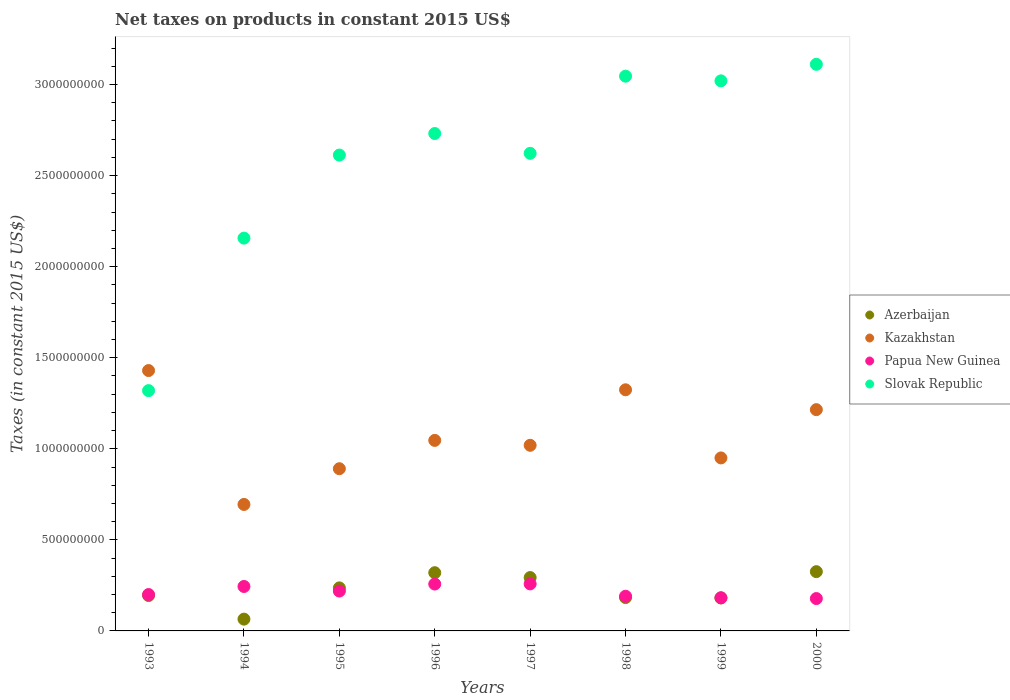Is the number of dotlines equal to the number of legend labels?
Your response must be concise. Yes. What is the net taxes on products in Kazakhstan in 1993?
Offer a very short reply. 1.43e+09. Across all years, what is the maximum net taxes on products in Kazakhstan?
Offer a very short reply. 1.43e+09. Across all years, what is the minimum net taxes on products in Papua New Guinea?
Provide a short and direct response. 1.78e+08. What is the total net taxes on products in Azerbaijan in the graph?
Offer a terse response. 1.80e+09. What is the difference between the net taxes on products in Azerbaijan in 1997 and that in 1999?
Your answer should be very brief. 1.12e+08. What is the difference between the net taxes on products in Slovak Republic in 1998 and the net taxes on products in Papua New Guinea in 1997?
Provide a short and direct response. 2.79e+09. What is the average net taxes on products in Slovak Republic per year?
Keep it short and to the point. 2.58e+09. In the year 1999, what is the difference between the net taxes on products in Kazakhstan and net taxes on products in Azerbaijan?
Your answer should be very brief. 7.69e+08. What is the ratio of the net taxes on products in Azerbaijan in 1995 to that in 2000?
Ensure brevity in your answer.  0.73. Is the net taxes on products in Kazakhstan in 1996 less than that in 1997?
Provide a short and direct response. No. What is the difference between the highest and the second highest net taxes on products in Papua New Guinea?
Give a very brief answer. 7.72e+05. What is the difference between the highest and the lowest net taxes on products in Slovak Republic?
Keep it short and to the point. 1.79e+09. In how many years, is the net taxes on products in Papua New Guinea greater than the average net taxes on products in Papua New Guinea taken over all years?
Keep it short and to the point. 4. Is the sum of the net taxes on products in Slovak Republic in 1995 and 2000 greater than the maximum net taxes on products in Papua New Guinea across all years?
Your response must be concise. Yes. Is it the case that in every year, the sum of the net taxes on products in Azerbaijan and net taxes on products in Kazakhstan  is greater than the sum of net taxes on products in Papua New Guinea and net taxes on products in Slovak Republic?
Keep it short and to the point. Yes. Does the net taxes on products in Slovak Republic monotonically increase over the years?
Offer a very short reply. No. Is the net taxes on products in Slovak Republic strictly greater than the net taxes on products in Kazakhstan over the years?
Offer a very short reply. No. Is the net taxes on products in Slovak Republic strictly less than the net taxes on products in Azerbaijan over the years?
Your answer should be compact. No. How many dotlines are there?
Your answer should be very brief. 4. What is the difference between two consecutive major ticks on the Y-axis?
Offer a terse response. 5.00e+08. Does the graph contain any zero values?
Give a very brief answer. No. How many legend labels are there?
Offer a terse response. 4. How are the legend labels stacked?
Offer a very short reply. Vertical. What is the title of the graph?
Give a very brief answer. Net taxes on products in constant 2015 US$. Does "Kyrgyz Republic" appear as one of the legend labels in the graph?
Ensure brevity in your answer.  No. What is the label or title of the Y-axis?
Your answer should be very brief. Taxes (in constant 2015 US$). What is the Taxes (in constant 2015 US$) in Azerbaijan in 1993?
Make the answer very short. 1.94e+08. What is the Taxes (in constant 2015 US$) in Kazakhstan in 1993?
Your response must be concise. 1.43e+09. What is the Taxes (in constant 2015 US$) in Papua New Guinea in 1993?
Offer a terse response. 2.00e+08. What is the Taxes (in constant 2015 US$) of Slovak Republic in 1993?
Offer a terse response. 1.32e+09. What is the Taxes (in constant 2015 US$) in Azerbaijan in 1994?
Keep it short and to the point. 6.47e+07. What is the Taxes (in constant 2015 US$) in Kazakhstan in 1994?
Make the answer very short. 6.94e+08. What is the Taxes (in constant 2015 US$) of Papua New Guinea in 1994?
Keep it short and to the point. 2.44e+08. What is the Taxes (in constant 2015 US$) of Slovak Republic in 1994?
Your response must be concise. 2.16e+09. What is the Taxes (in constant 2015 US$) of Azerbaijan in 1995?
Make the answer very short. 2.36e+08. What is the Taxes (in constant 2015 US$) in Kazakhstan in 1995?
Provide a succinct answer. 8.91e+08. What is the Taxes (in constant 2015 US$) in Papua New Guinea in 1995?
Make the answer very short. 2.19e+08. What is the Taxes (in constant 2015 US$) in Slovak Republic in 1995?
Provide a succinct answer. 2.61e+09. What is the Taxes (in constant 2015 US$) of Azerbaijan in 1996?
Offer a terse response. 3.20e+08. What is the Taxes (in constant 2015 US$) in Kazakhstan in 1996?
Keep it short and to the point. 1.05e+09. What is the Taxes (in constant 2015 US$) in Papua New Guinea in 1996?
Your answer should be compact. 2.57e+08. What is the Taxes (in constant 2015 US$) of Slovak Republic in 1996?
Your response must be concise. 2.73e+09. What is the Taxes (in constant 2015 US$) of Azerbaijan in 1997?
Your answer should be compact. 2.93e+08. What is the Taxes (in constant 2015 US$) of Kazakhstan in 1997?
Ensure brevity in your answer.  1.02e+09. What is the Taxes (in constant 2015 US$) of Papua New Guinea in 1997?
Your answer should be very brief. 2.58e+08. What is the Taxes (in constant 2015 US$) of Slovak Republic in 1997?
Your response must be concise. 2.62e+09. What is the Taxes (in constant 2015 US$) in Azerbaijan in 1998?
Your answer should be very brief. 1.83e+08. What is the Taxes (in constant 2015 US$) in Kazakhstan in 1998?
Your answer should be compact. 1.32e+09. What is the Taxes (in constant 2015 US$) in Papua New Guinea in 1998?
Your answer should be very brief. 1.90e+08. What is the Taxes (in constant 2015 US$) in Slovak Republic in 1998?
Provide a succinct answer. 3.05e+09. What is the Taxes (in constant 2015 US$) in Azerbaijan in 1999?
Make the answer very short. 1.81e+08. What is the Taxes (in constant 2015 US$) of Kazakhstan in 1999?
Provide a short and direct response. 9.50e+08. What is the Taxes (in constant 2015 US$) of Papua New Guinea in 1999?
Your answer should be very brief. 1.82e+08. What is the Taxes (in constant 2015 US$) of Slovak Republic in 1999?
Your answer should be compact. 3.02e+09. What is the Taxes (in constant 2015 US$) of Azerbaijan in 2000?
Offer a terse response. 3.25e+08. What is the Taxes (in constant 2015 US$) in Kazakhstan in 2000?
Offer a very short reply. 1.21e+09. What is the Taxes (in constant 2015 US$) of Papua New Guinea in 2000?
Give a very brief answer. 1.78e+08. What is the Taxes (in constant 2015 US$) in Slovak Republic in 2000?
Your answer should be compact. 3.11e+09. Across all years, what is the maximum Taxes (in constant 2015 US$) in Azerbaijan?
Ensure brevity in your answer.  3.25e+08. Across all years, what is the maximum Taxes (in constant 2015 US$) of Kazakhstan?
Keep it short and to the point. 1.43e+09. Across all years, what is the maximum Taxes (in constant 2015 US$) in Papua New Guinea?
Provide a short and direct response. 2.58e+08. Across all years, what is the maximum Taxes (in constant 2015 US$) in Slovak Republic?
Your answer should be very brief. 3.11e+09. Across all years, what is the minimum Taxes (in constant 2015 US$) in Azerbaijan?
Keep it short and to the point. 6.47e+07. Across all years, what is the minimum Taxes (in constant 2015 US$) of Kazakhstan?
Provide a short and direct response. 6.94e+08. Across all years, what is the minimum Taxes (in constant 2015 US$) in Papua New Guinea?
Ensure brevity in your answer.  1.78e+08. Across all years, what is the minimum Taxes (in constant 2015 US$) of Slovak Republic?
Offer a terse response. 1.32e+09. What is the total Taxes (in constant 2015 US$) in Azerbaijan in the graph?
Make the answer very short. 1.80e+09. What is the total Taxes (in constant 2015 US$) of Kazakhstan in the graph?
Your answer should be compact. 8.57e+09. What is the total Taxes (in constant 2015 US$) of Papua New Guinea in the graph?
Provide a short and direct response. 1.73e+09. What is the total Taxes (in constant 2015 US$) of Slovak Republic in the graph?
Keep it short and to the point. 2.06e+1. What is the difference between the Taxes (in constant 2015 US$) of Azerbaijan in 1993 and that in 1994?
Make the answer very short. 1.30e+08. What is the difference between the Taxes (in constant 2015 US$) of Kazakhstan in 1993 and that in 1994?
Provide a succinct answer. 7.35e+08. What is the difference between the Taxes (in constant 2015 US$) in Papua New Guinea in 1993 and that in 1994?
Keep it short and to the point. -4.43e+07. What is the difference between the Taxes (in constant 2015 US$) of Slovak Republic in 1993 and that in 1994?
Provide a succinct answer. -8.37e+08. What is the difference between the Taxes (in constant 2015 US$) in Azerbaijan in 1993 and that in 1995?
Your response must be concise. -4.20e+07. What is the difference between the Taxes (in constant 2015 US$) of Kazakhstan in 1993 and that in 1995?
Your answer should be compact. 5.39e+08. What is the difference between the Taxes (in constant 2015 US$) of Papua New Guinea in 1993 and that in 1995?
Offer a very short reply. -1.91e+07. What is the difference between the Taxes (in constant 2015 US$) of Slovak Republic in 1993 and that in 1995?
Give a very brief answer. -1.29e+09. What is the difference between the Taxes (in constant 2015 US$) of Azerbaijan in 1993 and that in 1996?
Offer a terse response. -1.25e+08. What is the difference between the Taxes (in constant 2015 US$) of Kazakhstan in 1993 and that in 1996?
Make the answer very short. 3.83e+08. What is the difference between the Taxes (in constant 2015 US$) in Papua New Guinea in 1993 and that in 1996?
Offer a terse response. -5.75e+07. What is the difference between the Taxes (in constant 2015 US$) of Slovak Republic in 1993 and that in 1996?
Provide a short and direct response. -1.41e+09. What is the difference between the Taxes (in constant 2015 US$) in Azerbaijan in 1993 and that in 1997?
Your answer should be very brief. -9.87e+07. What is the difference between the Taxes (in constant 2015 US$) in Kazakhstan in 1993 and that in 1997?
Give a very brief answer. 4.10e+08. What is the difference between the Taxes (in constant 2015 US$) of Papua New Guinea in 1993 and that in 1997?
Ensure brevity in your answer.  -5.83e+07. What is the difference between the Taxes (in constant 2015 US$) in Slovak Republic in 1993 and that in 1997?
Offer a terse response. -1.30e+09. What is the difference between the Taxes (in constant 2015 US$) in Azerbaijan in 1993 and that in 1998?
Offer a very short reply. 1.11e+07. What is the difference between the Taxes (in constant 2015 US$) of Kazakhstan in 1993 and that in 1998?
Provide a short and direct response. 1.06e+08. What is the difference between the Taxes (in constant 2015 US$) in Papua New Guinea in 1993 and that in 1998?
Give a very brief answer. 9.37e+06. What is the difference between the Taxes (in constant 2015 US$) of Slovak Republic in 1993 and that in 1998?
Your answer should be very brief. -1.73e+09. What is the difference between the Taxes (in constant 2015 US$) of Azerbaijan in 1993 and that in 1999?
Keep it short and to the point. 1.33e+07. What is the difference between the Taxes (in constant 2015 US$) in Kazakhstan in 1993 and that in 1999?
Provide a short and direct response. 4.80e+08. What is the difference between the Taxes (in constant 2015 US$) in Papua New Guinea in 1993 and that in 1999?
Your answer should be compact. 1.79e+07. What is the difference between the Taxes (in constant 2015 US$) in Slovak Republic in 1993 and that in 1999?
Give a very brief answer. -1.70e+09. What is the difference between the Taxes (in constant 2015 US$) of Azerbaijan in 1993 and that in 2000?
Provide a short and direct response. -1.31e+08. What is the difference between the Taxes (in constant 2015 US$) of Kazakhstan in 1993 and that in 2000?
Your response must be concise. 2.15e+08. What is the difference between the Taxes (in constant 2015 US$) in Papua New Guinea in 1993 and that in 2000?
Provide a succinct answer. 2.21e+07. What is the difference between the Taxes (in constant 2015 US$) of Slovak Republic in 1993 and that in 2000?
Your answer should be compact. -1.79e+09. What is the difference between the Taxes (in constant 2015 US$) of Azerbaijan in 1994 and that in 1995?
Keep it short and to the point. -1.72e+08. What is the difference between the Taxes (in constant 2015 US$) of Kazakhstan in 1994 and that in 1995?
Your answer should be compact. -1.96e+08. What is the difference between the Taxes (in constant 2015 US$) in Papua New Guinea in 1994 and that in 1995?
Offer a terse response. 2.52e+07. What is the difference between the Taxes (in constant 2015 US$) of Slovak Republic in 1994 and that in 1995?
Your response must be concise. -4.56e+08. What is the difference between the Taxes (in constant 2015 US$) of Azerbaijan in 1994 and that in 1996?
Your answer should be very brief. -2.55e+08. What is the difference between the Taxes (in constant 2015 US$) of Kazakhstan in 1994 and that in 1996?
Your response must be concise. -3.52e+08. What is the difference between the Taxes (in constant 2015 US$) of Papua New Guinea in 1994 and that in 1996?
Offer a very short reply. -1.33e+07. What is the difference between the Taxes (in constant 2015 US$) of Slovak Republic in 1994 and that in 1996?
Provide a short and direct response. -5.74e+08. What is the difference between the Taxes (in constant 2015 US$) of Azerbaijan in 1994 and that in 1997?
Your response must be concise. -2.28e+08. What is the difference between the Taxes (in constant 2015 US$) of Kazakhstan in 1994 and that in 1997?
Keep it short and to the point. -3.25e+08. What is the difference between the Taxes (in constant 2015 US$) in Papua New Guinea in 1994 and that in 1997?
Offer a very short reply. -1.41e+07. What is the difference between the Taxes (in constant 2015 US$) in Slovak Republic in 1994 and that in 1997?
Ensure brevity in your answer.  -4.66e+08. What is the difference between the Taxes (in constant 2015 US$) of Azerbaijan in 1994 and that in 1998?
Make the answer very short. -1.18e+08. What is the difference between the Taxes (in constant 2015 US$) of Kazakhstan in 1994 and that in 1998?
Provide a succinct answer. -6.30e+08. What is the difference between the Taxes (in constant 2015 US$) of Papua New Guinea in 1994 and that in 1998?
Ensure brevity in your answer.  5.36e+07. What is the difference between the Taxes (in constant 2015 US$) of Slovak Republic in 1994 and that in 1998?
Keep it short and to the point. -8.89e+08. What is the difference between the Taxes (in constant 2015 US$) of Azerbaijan in 1994 and that in 1999?
Provide a short and direct response. -1.16e+08. What is the difference between the Taxes (in constant 2015 US$) of Kazakhstan in 1994 and that in 1999?
Offer a very short reply. -2.55e+08. What is the difference between the Taxes (in constant 2015 US$) in Papua New Guinea in 1994 and that in 1999?
Your answer should be compact. 6.22e+07. What is the difference between the Taxes (in constant 2015 US$) in Slovak Republic in 1994 and that in 1999?
Offer a terse response. -8.64e+08. What is the difference between the Taxes (in constant 2015 US$) of Azerbaijan in 1994 and that in 2000?
Your response must be concise. -2.61e+08. What is the difference between the Taxes (in constant 2015 US$) of Kazakhstan in 1994 and that in 2000?
Offer a terse response. -5.20e+08. What is the difference between the Taxes (in constant 2015 US$) in Papua New Guinea in 1994 and that in 2000?
Provide a short and direct response. 6.63e+07. What is the difference between the Taxes (in constant 2015 US$) of Slovak Republic in 1994 and that in 2000?
Provide a short and direct response. -9.54e+08. What is the difference between the Taxes (in constant 2015 US$) in Azerbaijan in 1995 and that in 1996?
Make the answer very short. -8.34e+07. What is the difference between the Taxes (in constant 2015 US$) in Kazakhstan in 1995 and that in 1996?
Give a very brief answer. -1.56e+08. What is the difference between the Taxes (in constant 2015 US$) in Papua New Guinea in 1995 and that in 1996?
Your answer should be compact. -3.85e+07. What is the difference between the Taxes (in constant 2015 US$) in Slovak Republic in 1995 and that in 1996?
Your response must be concise. -1.18e+08. What is the difference between the Taxes (in constant 2015 US$) in Azerbaijan in 1995 and that in 1997?
Provide a short and direct response. -5.67e+07. What is the difference between the Taxes (in constant 2015 US$) of Kazakhstan in 1995 and that in 1997?
Keep it short and to the point. -1.29e+08. What is the difference between the Taxes (in constant 2015 US$) in Papua New Guinea in 1995 and that in 1997?
Keep it short and to the point. -3.92e+07. What is the difference between the Taxes (in constant 2015 US$) of Slovak Republic in 1995 and that in 1997?
Make the answer very short. -9.45e+06. What is the difference between the Taxes (in constant 2015 US$) in Azerbaijan in 1995 and that in 1998?
Provide a short and direct response. 5.31e+07. What is the difference between the Taxes (in constant 2015 US$) in Kazakhstan in 1995 and that in 1998?
Your response must be concise. -4.33e+08. What is the difference between the Taxes (in constant 2015 US$) of Papua New Guinea in 1995 and that in 1998?
Offer a terse response. 2.85e+07. What is the difference between the Taxes (in constant 2015 US$) in Slovak Republic in 1995 and that in 1998?
Make the answer very short. -4.33e+08. What is the difference between the Taxes (in constant 2015 US$) in Azerbaijan in 1995 and that in 1999?
Your response must be concise. 5.53e+07. What is the difference between the Taxes (in constant 2015 US$) of Kazakhstan in 1995 and that in 1999?
Your answer should be compact. -5.92e+07. What is the difference between the Taxes (in constant 2015 US$) in Papua New Guinea in 1995 and that in 1999?
Provide a short and direct response. 3.70e+07. What is the difference between the Taxes (in constant 2015 US$) of Slovak Republic in 1995 and that in 1999?
Your response must be concise. -4.08e+08. What is the difference between the Taxes (in constant 2015 US$) in Azerbaijan in 1995 and that in 2000?
Offer a terse response. -8.91e+07. What is the difference between the Taxes (in constant 2015 US$) of Kazakhstan in 1995 and that in 2000?
Your answer should be compact. -3.24e+08. What is the difference between the Taxes (in constant 2015 US$) of Papua New Guinea in 1995 and that in 2000?
Offer a very short reply. 4.12e+07. What is the difference between the Taxes (in constant 2015 US$) in Slovak Republic in 1995 and that in 2000?
Provide a short and direct response. -4.98e+08. What is the difference between the Taxes (in constant 2015 US$) of Azerbaijan in 1996 and that in 1997?
Ensure brevity in your answer.  2.67e+07. What is the difference between the Taxes (in constant 2015 US$) of Kazakhstan in 1996 and that in 1997?
Make the answer very short. 2.69e+07. What is the difference between the Taxes (in constant 2015 US$) in Papua New Guinea in 1996 and that in 1997?
Provide a succinct answer. -7.72e+05. What is the difference between the Taxes (in constant 2015 US$) of Slovak Republic in 1996 and that in 1997?
Your response must be concise. 1.09e+08. What is the difference between the Taxes (in constant 2015 US$) in Azerbaijan in 1996 and that in 1998?
Ensure brevity in your answer.  1.36e+08. What is the difference between the Taxes (in constant 2015 US$) of Kazakhstan in 1996 and that in 1998?
Your answer should be very brief. -2.78e+08. What is the difference between the Taxes (in constant 2015 US$) of Papua New Guinea in 1996 and that in 1998?
Your answer should be compact. 6.69e+07. What is the difference between the Taxes (in constant 2015 US$) of Slovak Republic in 1996 and that in 1998?
Your answer should be very brief. -3.15e+08. What is the difference between the Taxes (in constant 2015 US$) in Azerbaijan in 1996 and that in 1999?
Provide a succinct answer. 1.39e+08. What is the difference between the Taxes (in constant 2015 US$) in Kazakhstan in 1996 and that in 1999?
Provide a succinct answer. 9.63e+07. What is the difference between the Taxes (in constant 2015 US$) in Papua New Guinea in 1996 and that in 1999?
Provide a succinct answer. 7.55e+07. What is the difference between the Taxes (in constant 2015 US$) of Slovak Republic in 1996 and that in 1999?
Offer a terse response. -2.89e+08. What is the difference between the Taxes (in constant 2015 US$) in Azerbaijan in 1996 and that in 2000?
Your answer should be compact. -5.73e+06. What is the difference between the Taxes (in constant 2015 US$) of Kazakhstan in 1996 and that in 2000?
Provide a short and direct response. -1.69e+08. What is the difference between the Taxes (in constant 2015 US$) in Papua New Guinea in 1996 and that in 2000?
Provide a succinct answer. 7.96e+07. What is the difference between the Taxes (in constant 2015 US$) in Slovak Republic in 1996 and that in 2000?
Your answer should be compact. -3.80e+08. What is the difference between the Taxes (in constant 2015 US$) of Azerbaijan in 1997 and that in 1998?
Your answer should be compact. 1.10e+08. What is the difference between the Taxes (in constant 2015 US$) of Kazakhstan in 1997 and that in 1998?
Ensure brevity in your answer.  -3.05e+08. What is the difference between the Taxes (in constant 2015 US$) of Papua New Guinea in 1997 and that in 1998?
Ensure brevity in your answer.  6.77e+07. What is the difference between the Taxes (in constant 2015 US$) of Slovak Republic in 1997 and that in 1998?
Provide a short and direct response. -4.24e+08. What is the difference between the Taxes (in constant 2015 US$) of Azerbaijan in 1997 and that in 1999?
Provide a short and direct response. 1.12e+08. What is the difference between the Taxes (in constant 2015 US$) in Kazakhstan in 1997 and that in 1999?
Give a very brief answer. 6.93e+07. What is the difference between the Taxes (in constant 2015 US$) of Papua New Guinea in 1997 and that in 1999?
Offer a terse response. 7.63e+07. What is the difference between the Taxes (in constant 2015 US$) in Slovak Republic in 1997 and that in 1999?
Provide a succinct answer. -3.98e+08. What is the difference between the Taxes (in constant 2015 US$) of Azerbaijan in 1997 and that in 2000?
Provide a short and direct response. -3.24e+07. What is the difference between the Taxes (in constant 2015 US$) of Kazakhstan in 1997 and that in 2000?
Provide a succinct answer. -1.96e+08. What is the difference between the Taxes (in constant 2015 US$) of Papua New Guinea in 1997 and that in 2000?
Offer a very short reply. 8.04e+07. What is the difference between the Taxes (in constant 2015 US$) of Slovak Republic in 1997 and that in 2000?
Provide a succinct answer. -4.89e+08. What is the difference between the Taxes (in constant 2015 US$) of Azerbaijan in 1998 and that in 1999?
Provide a short and direct response. 2.16e+06. What is the difference between the Taxes (in constant 2015 US$) in Kazakhstan in 1998 and that in 1999?
Offer a terse response. 3.74e+08. What is the difference between the Taxes (in constant 2015 US$) of Papua New Guinea in 1998 and that in 1999?
Make the answer very short. 8.57e+06. What is the difference between the Taxes (in constant 2015 US$) in Slovak Republic in 1998 and that in 1999?
Offer a very short reply. 2.57e+07. What is the difference between the Taxes (in constant 2015 US$) of Azerbaijan in 1998 and that in 2000?
Keep it short and to the point. -1.42e+08. What is the difference between the Taxes (in constant 2015 US$) in Kazakhstan in 1998 and that in 2000?
Your response must be concise. 1.09e+08. What is the difference between the Taxes (in constant 2015 US$) of Papua New Guinea in 1998 and that in 2000?
Offer a terse response. 1.27e+07. What is the difference between the Taxes (in constant 2015 US$) of Slovak Republic in 1998 and that in 2000?
Your answer should be very brief. -6.50e+07. What is the difference between the Taxes (in constant 2015 US$) of Azerbaijan in 1999 and that in 2000?
Keep it short and to the point. -1.44e+08. What is the difference between the Taxes (in constant 2015 US$) of Kazakhstan in 1999 and that in 2000?
Your response must be concise. -2.65e+08. What is the difference between the Taxes (in constant 2015 US$) in Papua New Guinea in 1999 and that in 2000?
Your answer should be very brief. 4.15e+06. What is the difference between the Taxes (in constant 2015 US$) in Slovak Republic in 1999 and that in 2000?
Make the answer very short. -9.08e+07. What is the difference between the Taxes (in constant 2015 US$) in Azerbaijan in 1993 and the Taxes (in constant 2015 US$) in Kazakhstan in 1994?
Make the answer very short. -5.00e+08. What is the difference between the Taxes (in constant 2015 US$) of Azerbaijan in 1993 and the Taxes (in constant 2015 US$) of Papua New Guinea in 1994?
Your answer should be very brief. -4.98e+07. What is the difference between the Taxes (in constant 2015 US$) of Azerbaijan in 1993 and the Taxes (in constant 2015 US$) of Slovak Republic in 1994?
Ensure brevity in your answer.  -1.96e+09. What is the difference between the Taxes (in constant 2015 US$) of Kazakhstan in 1993 and the Taxes (in constant 2015 US$) of Papua New Guinea in 1994?
Your answer should be compact. 1.19e+09. What is the difference between the Taxes (in constant 2015 US$) in Kazakhstan in 1993 and the Taxes (in constant 2015 US$) in Slovak Republic in 1994?
Keep it short and to the point. -7.27e+08. What is the difference between the Taxes (in constant 2015 US$) of Papua New Guinea in 1993 and the Taxes (in constant 2015 US$) of Slovak Republic in 1994?
Ensure brevity in your answer.  -1.96e+09. What is the difference between the Taxes (in constant 2015 US$) of Azerbaijan in 1993 and the Taxes (in constant 2015 US$) of Kazakhstan in 1995?
Offer a terse response. -6.96e+08. What is the difference between the Taxes (in constant 2015 US$) of Azerbaijan in 1993 and the Taxes (in constant 2015 US$) of Papua New Guinea in 1995?
Your response must be concise. -2.46e+07. What is the difference between the Taxes (in constant 2015 US$) in Azerbaijan in 1993 and the Taxes (in constant 2015 US$) in Slovak Republic in 1995?
Provide a succinct answer. -2.42e+09. What is the difference between the Taxes (in constant 2015 US$) of Kazakhstan in 1993 and the Taxes (in constant 2015 US$) of Papua New Guinea in 1995?
Provide a succinct answer. 1.21e+09. What is the difference between the Taxes (in constant 2015 US$) in Kazakhstan in 1993 and the Taxes (in constant 2015 US$) in Slovak Republic in 1995?
Ensure brevity in your answer.  -1.18e+09. What is the difference between the Taxes (in constant 2015 US$) of Papua New Guinea in 1993 and the Taxes (in constant 2015 US$) of Slovak Republic in 1995?
Offer a very short reply. -2.41e+09. What is the difference between the Taxes (in constant 2015 US$) in Azerbaijan in 1993 and the Taxes (in constant 2015 US$) in Kazakhstan in 1996?
Make the answer very short. -8.52e+08. What is the difference between the Taxes (in constant 2015 US$) in Azerbaijan in 1993 and the Taxes (in constant 2015 US$) in Papua New Guinea in 1996?
Make the answer very short. -6.31e+07. What is the difference between the Taxes (in constant 2015 US$) of Azerbaijan in 1993 and the Taxes (in constant 2015 US$) of Slovak Republic in 1996?
Keep it short and to the point. -2.54e+09. What is the difference between the Taxes (in constant 2015 US$) in Kazakhstan in 1993 and the Taxes (in constant 2015 US$) in Papua New Guinea in 1996?
Your response must be concise. 1.17e+09. What is the difference between the Taxes (in constant 2015 US$) of Kazakhstan in 1993 and the Taxes (in constant 2015 US$) of Slovak Republic in 1996?
Give a very brief answer. -1.30e+09. What is the difference between the Taxes (in constant 2015 US$) in Papua New Guinea in 1993 and the Taxes (in constant 2015 US$) in Slovak Republic in 1996?
Offer a terse response. -2.53e+09. What is the difference between the Taxes (in constant 2015 US$) in Azerbaijan in 1993 and the Taxes (in constant 2015 US$) in Kazakhstan in 1997?
Your response must be concise. -8.25e+08. What is the difference between the Taxes (in constant 2015 US$) in Azerbaijan in 1993 and the Taxes (in constant 2015 US$) in Papua New Guinea in 1997?
Give a very brief answer. -6.38e+07. What is the difference between the Taxes (in constant 2015 US$) in Azerbaijan in 1993 and the Taxes (in constant 2015 US$) in Slovak Republic in 1997?
Give a very brief answer. -2.43e+09. What is the difference between the Taxes (in constant 2015 US$) in Kazakhstan in 1993 and the Taxes (in constant 2015 US$) in Papua New Guinea in 1997?
Provide a short and direct response. 1.17e+09. What is the difference between the Taxes (in constant 2015 US$) of Kazakhstan in 1993 and the Taxes (in constant 2015 US$) of Slovak Republic in 1997?
Ensure brevity in your answer.  -1.19e+09. What is the difference between the Taxes (in constant 2015 US$) of Papua New Guinea in 1993 and the Taxes (in constant 2015 US$) of Slovak Republic in 1997?
Make the answer very short. -2.42e+09. What is the difference between the Taxes (in constant 2015 US$) in Azerbaijan in 1993 and the Taxes (in constant 2015 US$) in Kazakhstan in 1998?
Give a very brief answer. -1.13e+09. What is the difference between the Taxes (in constant 2015 US$) in Azerbaijan in 1993 and the Taxes (in constant 2015 US$) in Papua New Guinea in 1998?
Make the answer very short. 3.85e+06. What is the difference between the Taxes (in constant 2015 US$) in Azerbaijan in 1993 and the Taxes (in constant 2015 US$) in Slovak Republic in 1998?
Give a very brief answer. -2.85e+09. What is the difference between the Taxes (in constant 2015 US$) in Kazakhstan in 1993 and the Taxes (in constant 2015 US$) in Papua New Guinea in 1998?
Ensure brevity in your answer.  1.24e+09. What is the difference between the Taxes (in constant 2015 US$) of Kazakhstan in 1993 and the Taxes (in constant 2015 US$) of Slovak Republic in 1998?
Your answer should be compact. -1.62e+09. What is the difference between the Taxes (in constant 2015 US$) of Papua New Guinea in 1993 and the Taxes (in constant 2015 US$) of Slovak Republic in 1998?
Give a very brief answer. -2.85e+09. What is the difference between the Taxes (in constant 2015 US$) in Azerbaijan in 1993 and the Taxes (in constant 2015 US$) in Kazakhstan in 1999?
Offer a terse response. -7.56e+08. What is the difference between the Taxes (in constant 2015 US$) in Azerbaijan in 1993 and the Taxes (in constant 2015 US$) in Papua New Guinea in 1999?
Give a very brief answer. 1.24e+07. What is the difference between the Taxes (in constant 2015 US$) of Azerbaijan in 1993 and the Taxes (in constant 2015 US$) of Slovak Republic in 1999?
Provide a short and direct response. -2.83e+09. What is the difference between the Taxes (in constant 2015 US$) of Kazakhstan in 1993 and the Taxes (in constant 2015 US$) of Papua New Guinea in 1999?
Make the answer very short. 1.25e+09. What is the difference between the Taxes (in constant 2015 US$) of Kazakhstan in 1993 and the Taxes (in constant 2015 US$) of Slovak Republic in 1999?
Offer a terse response. -1.59e+09. What is the difference between the Taxes (in constant 2015 US$) of Papua New Guinea in 1993 and the Taxes (in constant 2015 US$) of Slovak Republic in 1999?
Offer a very short reply. -2.82e+09. What is the difference between the Taxes (in constant 2015 US$) of Azerbaijan in 1993 and the Taxes (in constant 2015 US$) of Kazakhstan in 2000?
Ensure brevity in your answer.  -1.02e+09. What is the difference between the Taxes (in constant 2015 US$) in Azerbaijan in 1993 and the Taxes (in constant 2015 US$) in Papua New Guinea in 2000?
Your response must be concise. 1.66e+07. What is the difference between the Taxes (in constant 2015 US$) in Azerbaijan in 1993 and the Taxes (in constant 2015 US$) in Slovak Republic in 2000?
Your answer should be very brief. -2.92e+09. What is the difference between the Taxes (in constant 2015 US$) of Kazakhstan in 1993 and the Taxes (in constant 2015 US$) of Papua New Guinea in 2000?
Your response must be concise. 1.25e+09. What is the difference between the Taxes (in constant 2015 US$) in Kazakhstan in 1993 and the Taxes (in constant 2015 US$) in Slovak Republic in 2000?
Provide a succinct answer. -1.68e+09. What is the difference between the Taxes (in constant 2015 US$) of Papua New Guinea in 1993 and the Taxes (in constant 2015 US$) of Slovak Republic in 2000?
Give a very brief answer. -2.91e+09. What is the difference between the Taxes (in constant 2015 US$) of Azerbaijan in 1994 and the Taxes (in constant 2015 US$) of Kazakhstan in 1995?
Offer a very short reply. -8.26e+08. What is the difference between the Taxes (in constant 2015 US$) of Azerbaijan in 1994 and the Taxes (in constant 2015 US$) of Papua New Guinea in 1995?
Your answer should be very brief. -1.54e+08. What is the difference between the Taxes (in constant 2015 US$) in Azerbaijan in 1994 and the Taxes (in constant 2015 US$) in Slovak Republic in 1995?
Your answer should be compact. -2.55e+09. What is the difference between the Taxes (in constant 2015 US$) in Kazakhstan in 1994 and the Taxes (in constant 2015 US$) in Papua New Guinea in 1995?
Make the answer very short. 4.76e+08. What is the difference between the Taxes (in constant 2015 US$) of Kazakhstan in 1994 and the Taxes (in constant 2015 US$) of Slovak Republic in 1995?
Give a very brief answer. -1.92e+09. What is the difference between the Taxes (in constant 2015 US$) of Papua New Guinea in 1994 and the Taxes (in constant 2015 US$) of Slovak Republic in 1995?
Your answer should be compact. -2.37e+09. What is the difference between the Taxes (in constant 2015 US$) of Azerbaijan in 1994 and the Taxes (in constant 2015 US$) of Kazakhstan in 1996?
Ensure brevity in your answer.  -9.81e+08. What is the difference between the Taxes (in constant 2015 US$) in Azerbaijan in 1994 and the Taxes (in constant 2015 US$) in Papua New Guinea in 1996?
Offer a very short reply. -1.93e+08. What is the difference between the Taxes (in constant 2015 US$) in Azerbaijan in 1994 and the Taxes (in constant 2015 US$) in Slovak Republic in 1996?
Provide a short and direct response. -2.67e+09. What is the difference between the Taxes (in constant 2015 US$) of Kazakhstan in 1994 and the Taxes (in constant 2015 US$) of Papua New Guinea in 1996?
Your answer should be compact. 4.37e+08. What is the difference between the Taxes (in constant 2015 US$) in Kazakhstan in 1994 and the Taxes (in constant 2015 US$) in Slovak Republic in 1996?
Offer a terse response. -2.04e+09. What is the difference between the Taxes (in constant 2015 US$) in Papua New Guinea in 1994 and the Taxes (in constant 2015 US$) in Slovak Republic in 1996?
Provide a succinct answer. -2.49e+09. What is the difference between the Taxes (in constant 2015 US$) in Azerbaijan in 1994 and the Taxes (in constant 2015 US$) in Kazakhstan in 1997?
Keep it short and to the point. -9.54e+08. What is the difference between the Taxes (in constant 2015 US$) of Azerbaijan in 1994 and the Taxes (in constant 2015 US$) of Papua New Guinea in 1997?
Offer a very short reply. -1.93e+08. What is the difference between the Taxes (in constant 2015 US$) of Azerbaijan in 1994 and the Taxes (in constant 2015 US$) of Slovak Republic in 1997?
Offer a very short reply. -2.56e+09. What is the difference between the Taxes (in constant 2015 US$) in Kazakhstan in 1994 and the Taxes (in constant 2015 US$) in Papua New Guinea in 1997?
Keep it short and to the point. 4.36e+08. What is the difference between the Taxes (in constant 2015 US$) of Kazakhstan in 1994 and the Taxes (in constant 2015 US$) of Slovak Republic in 1997?
Ensure brevity in your answer.  -1.93e+09. What is the difference between the Taxes (in constant 2015 US$) of Papua New Guinea in 1994 and the Taxes (in constant 2015 US$) of Slovak Republic in 1997?
Your answer should be compact. -2.38e+09. What is the difference between the Taxes (in constant 2015 US$) of Azerbaijan in 1994 and the Taxes (in constant 2015 US$) of Kazakhstan in 1998?
Your response must be concise. -1.26e+09. What is the difference between the Taxes (in constant 2015 US$) of Azerbaijan in 1994 and the Taxes (in constant 2015 US$) of Papua New Guinea in 1998?
Offer a very short reply. -1.26e+08. What is the difference between the Taxes (in constant 2015 US$) of Azerbaijan in 1994 and the Taxes (in constant 2015 US$) of Slovak Republic in 1998?
Make the answer very short. -2.98e+09. What is the difference between the Taxes (in constant 2015 US$) of Kazakhstan in 1994 and the Taxes (in constant 2015 US$) of Papua New Guinea in 1998?
Offer a terse response. 5.04e+08. What is the difference between the Taxes (in constant 2015 US$) in Kazakhstan in 1994 and the Taxes (in constant 2015 US$) in Slovak Republic in 1998?
Offer a very short reply. -2.35e+09. What is the difference between the Taxes (in constant 2015 US$) of Papua New Guinea in 1994 and the Taxes (in constant 2015 US$) of Slovak Republic in 1998?
Give a very brief answer. -2.80e+09. What is the difference between the Taxes (in constant 2015 US$) of Azerbaijan in 1994 and the Taxes (in constant 2015 US$) of Kazakhstan in 1999?
Offer a terse response. -8.85e+08. What is the difference between the Taxes (in constant 2015 US$) in Azerbaijan in 1994 and the Taxes (in constant 2015 US$) in Papua New Guinea in 1999?
Your answer should be compact. -1.17e+08. What is the difference between the Taxes (in constant 2015 US$) of Azerbaijan in 1994 and the Taxes (in constant 2015 US$) of Slovak Republic in 1999?
Your answer should be compact. -2.96e+09. What is the difference between the Taxes (in constant 2015 US$) in Kazakhstan in 1994 and the Taxes (in constant 2015 US$) in Papua New Guinea in 1999?
Give a very brief answer. 5.13e+08. What is the difference between the Taxes (in constant 2015 US$) of Kazakhstan in 1994 and the Taxes (in constant 2015 US$) of Slovak Republic in 1999?
Provide a succinct answer. -2.33e+09. What is the difference between the Taxes (in constant 2015 US$) of Papua New Guinea in 1994 and the Taxes (in constant 2015 US$) of Slovak Republic in 1999?
Make the answer very short. -2.78e+09. What is the difference between the Taxes (in constant 2015 US$) in Azerbaijan in 1994 and the Taxes (in constant 2015 US$) in Kazakhstan in 2000?
Offer a very short reply. -1.15e+09. What is the difference between the Taxes (in constant 2015 US$) of Azerbaijan in 1994 and the Taxes (in constant 2015 US$) of Papua New Guinea in 2000?
Make the answer very short. -1.13e+08. What is the difference between the Taxes (in constant 2015 US$) of Azerbaijan in 1994 and the Taxes (in constant 2015 US$) of Slovak Republic in 2000?
Ensure brevity in your answer.  -3.05e+09. What is the difference between the Taxes (in constant 2015 US$) of Kazakhstan in 1994 and the Taxes (in constant 2015 US$) of Papua New Guinea in 2000?
Offer a terse response. 5.17e+08. What is the difference between the Taxes (in constant 2015 US$) in Kazakhstan in 1994 and the Taxes (in constant 2015 US$) in Slovak Republic in 2000?
Keep it short and to the point. -2.42e+09. What is the difference between the Taxes (in constant 2015 US$) in Papua New Guinea in 1994 and the Taxes (in constant 2015 US$) in Slovak Republic in 2000?
Make the answer very short. -2.87e+09. What is the difference between the Taxes (in constant 2015 US$) in Azerbaijan in 1995 and the Taxes (in constant 2015 US$) in Kazakhstan in 1996?
Keep it short and to the point. -8.10e+08. What is the difference between the Taxes (in constant 2015 US$) of Azerbaijan in 1995 and the Taxes (in constant 2015 US$) of Papua New Guinea in 1996?
Offer a very short reply. -2.10e+07. What is the difference between the Taxes (in constant 2015 US$) in Azerbaijan in 1995 and the Taxes (in constant 2015 US$) in Slovak Republic in 1996?
Keep it short and to the point. -2.49e+09. What is the difference between the Taxes (in constant 2015 US$) in Kazakhstan in 1995 and the Taxes (in constant 2015 US$) in Papua New Guinea in 1996?
Ensure brevity in your answer.  6.33e+08. What is the difference between the Taxes (in constant 2015 US$) in Kazakhstan in 1995 and the Taxes (in constant 2015 US$) in Slovak Republic in 1996?
Give a very brief answer. -1.84e+09. What is the difference between the Taxes (in constant 2015 US$) in Papua New Guinea in 1995 and the Taxes (in constant 2015 US$) in Slovak Republic in 1996?
Give a very brief answer. -2.51e+09. What is the difference between the Taxes (in constant 2015 US$) in Azerbaijan in 1995 and the Taxes (in constant 2015 US$) in Kazakhstan in 1997?
Offer a very short reply. -7.83e+08. What is the difference between the Taxes (in constant 2015 US$) in Azerbaijan in 1995 and the Taxes (in constant 2015 US$) in Papua New Guinea in 1997?
Give a very brief answer. -2.18e+07. What is the difference between the Taxes (in constant 2015 US$) in Azerbaijan in 1995 and the Taxes (in constant 2015 US$) in Slovak Republic in 1997?
Your answer should be compact. -2.39e+09. What is the difference between the Taxes (in constant 2015 US$) in Kazakhstan in 1995 and the Taxes (in constant 2015 US$) in Papua New Guinea in 1997?
Keep it short and to the point. 6.32e+08. What is the difference between the Taxes (in constant 2015 US$) of Kazakhstan in 1995 and the Taxes (in constant 2015 US$) of Slovak Republic in 1997?
Your answer should be very brief. -1.73e+09. What is the difference between the Taxes (in constant 2015 US$) of Papua New Guinea in 1995 and the Taxes (in constant 2015 US$) of Slovak Republic in 1997?
Your response must be concise. -2.40e+09. What is the difference between the Taxes (in constant 2015 US$) of Azerbaijan in 1995 and the Taxes (in constant 2015 US$) of Kazakhstan in 1998?
Keep it short and to the point. -1.09e+09. What is the difference between the Taxes (in constant 2015 US$) of Azerbaijan in 1995 and the Taxes (in constant 2015 US$) of Papua New Guinea in 1998?
Offer a terse response. 4.59e+07. What is the difference between the Taxes (in constant 2015 US$) in Azerbaijan in 1995 and the Taxes (in constant 2015 US$) in Slovak Republic in 1998?
Provide a short and direct response. -2.81e+09. What is the difference between the Taxes (in constant 2015 US$) of Kazakhstan in 1995 and the Taxes (in constant 2015 US$) of Papua New Guinea in 1998?
Your answer should be very brief. 7.00e+08. What is the difference between the Taxes (in constant 2015 US$) of Kazakhstan in 1995 and the Taxes (in constant 2015 US$) of Slovak Republic in 1998?
Your response must be concise. -2.16e+09. What is the difference between the Taxes (in constant 2015 US$) in Papua New Guinea in 1995 and the Taxes (in constant 2015 US$) in Slovak Republic in 1998?
Offer a terse response. -2.83e+09. What is the difference between the Taxes (in constant 2015 US$) in Azerbaijan in 1995 and the Taxes (in constant 2015 US$) in Kazakhstan in 1999?
Give a very brief answer. -7.14e+08. What is the difference between the Taxes (in constant 2015 US$) of Azerbaijan in 1995 and the Taxes (in constant 2015 US$) of Papua New Guinea in 1999?
Keep it short and to the point. 5.44e+07. What is the difference between the Taxes (in constant 2015 US$) in Azerbaijan in 1995 and the Taxes (in constant 2015 US$) in Slovak Republic in 1999?
Your answer should be very brief. -2.78e+09. What is the difference between the Taxes (in constant 2015 US$) in Kazakhstan in 1995 and the Taxes (in constant 2015 US$) in Papua New Guinea in 1999?
Offer a terse response. 7.09e+08. What is the difference between the Taxes (in constant 2015 US$) in Kazakhstan in 1995 and the Taxes (in constant 2015 US$) in Slovak Republic in 1999?
Offer a terse response. -2.13e+09. What is the difference between the Taxes (in constant 2015 US$) of Papua New Guinea in 1995 and the Taxes (in constant 2015 US$) of Slovak Republic in 1999?
Provide a short and direct response. -2.80e+09. What is the difference between the Taxes (in constant 2015 US$) in Azerbaijan in 1995 and the Taxes (in constant 2015 US$) in Kazakhstan in 2000?
Your response must be concise. -9.79e+08. What is the difference between the Taxes (in constant 2015 US$) in Azerbaijan in 1995 and the Taxes (in constant 2015 US$) in Papua New Guinea in 2000?
Offer a very short reply. 5.86e+07. What is the difference between the Taxes (in constant 2015 US$) in Azerbaijan in 1995 and the Taxes (in constant 2015 US$) in Slovak Republic in 2000?
Your response must be concise. -2.87e+09. What is the difference between the Taxes (in constant 2015 US$) of Kazakhstan in 1995 and the Taxes (in constant 2015 US$) of Papua New Guinea in 2000?
Your answer should be compact. 7.13e+08. What is the difference between the Taxes (in constant 2015 US$) of Kazakhstan in 1995 and the Taxes (in constant 2015 US$) of Slovak Republic in 2000?
Offer a terse response. -2.22e+09. What is the difference between the Taxes (in constant 2015 US$) in Papua New Guinea in 1995 and the Taxes (in constant 2015 US$) in Slovak Republic in 2000?
Your response must be concise. -2.89e+09. What is the difference between the Taxes (in constant 2015 US$) of Azerbaijan in 1996 and the Taxes (in constant 2015 US$) of Kazakhstan in 1997?
Ensure brevity in your answer.  -6.99e+08. What is the difference between the Taxes (in constant 2015 US$) in Azerbaijan in 1996 and the Taxes (in constant 2015 US$) in Papua New Guinea in 1997?
Give a very brief answer. 6.16e+07. What is the difference between the Taxes (in constant 2015 US$) of Azerbaijan in 1996 and the Taxes (in constant 2015 US$) of Slovak Republic in 1997?
Give a very brief answer. -2.30e+09. What is the difference between the Taxes (in constant 2015 US$) in Kazakhstan in 1996 and the Taxes (in constant 2015 US$) in Papua New Guinea in 1997?
Offer a very short reply. 7.88e+08. What is the difference between the Taxes (in constant 2015 US$) in Kazakhstan in 1996 and the Taxes (in constant 2015 US$) in Slovak Republic in 1997?
Provide a succinct answer. -1.58e+09. What is the difference between the Taxes (in constant 2015 US$) of Papua New Guinea in 1996 and the Taxes (in constant 2015 US$) of Slovak Republic in 1997?
Give a very brief answer. -2.36e+09. What is the difference between the Taxes (in constant 2015 US$) of Azerbaijan in 1996 and the Taxes (in constant 2015 US$) of Kazakhstan in 1998?
Give a very brief answer. -1.00e+09. What is the difference between the Taxes (in constant 2015 US$) of Azerbaijan in 1996 and the Taxes (in constant 2015 US$) of Papua New Guinea in 1998?
Give a very brief answer. 1.29e+08. What is the difference between the Taxes (in constant 2015 US$) in Azerbaijan in 1996 and the Taxes (in constant 2015 US$) in Slovak Republic in 1998?
Your answer should be very brief. -2.73e+09. What is the difference between the Taxes (in constant 2015 US$) of Kazakhstan in 1996 and the Taxes (in constant 2015 US$) of Papua New Guinea in 1998?
Your response must be concise. 8.56e+08. What is the difference between the Taxes (in constant 2015 US$) in Kazakhstan in 1996 and the Taxes (in constant 2015 US$) in Slovak Republic in 1998?
Your answer should be compact. -2.00e+09. What is the difference between the Taxes (in constant 2015 US$) of Papua New Guinea in 1996 and the Taxes (in constant 2015 US$) of Slovak Republic in 1998?
Offer a very short reply. -2.79e+09. What is the difference between the Taxes (in constant 2015 US$) in Azerbaijan in 1996 and the Taxes (in constant 2015 US$) in Kazakhstan in 1999?
Ensure brevity in your answer.  -6.30e+08. What is the difference between the Taxes (in constant 2015 US$) in Azerbaijan in 1996 and the Taxes (in constant 2015 US$) in Papua New Guinea in 1999?
Offer a terse response. 1.38e+08. What is the difference between the Taxes (in constant 2015 US$) of Azerbaijan in 1996 and the Taxes (in constant 2015 US$) of Slovak Republic in 1999?
Provide a short and direct response. -2.70e+09. What is the difference between the Taxes (in constant 2015 US$) in Kazakhstan in 1996 and the Taxes (in constant 2015 US$) in Papua New Guinea in 1999?
Your answer should be very brief. 8.64e+08. What is the difference between the Taxes (in constant 2015 US$) in Kazakhstan in 1996 and the Taxes (in constant 2015 US$) in Slovak Republic in 1999?
Offer a terse response. -1.97e+09. What is the difference between the Taxes (in constant 2015 US$) of Papua New Guinea in 1996 and the Taxes (in constant 2015 US$) of Slovak Republic in 1999?
Your answer should be very brief. -2.76e+09. What is the difference between the Taxes (in constant 2015 US$) of Azerbaijan in 1996 and the Taxes (in constant 2015 US$) of Kazakhstan in 2000?
Your response must be concise. -8.95e+08. What is the difference between the Taxes (in constant 2015 US$) of Azerbaijan in 1996 and the Taxes (in constant 2015 US$) of Papua New Guinea in 2000?
Keep it short and to the point. 1.42e+08. What is the difference between the Taxes (in constant 2015 US$) of Azerbaijan in 1996 and the Taxes (in constant 2015 US$) of Slovak Republic in 2000?
Your answer should be compact. -2.79e+09. What is the difference between the Taxes (in constant 2015 US$) of Kazakhstan in 1996 and the Taxes (in constant 2015 US$) of Papua New Guinea in 2000?
Your answer should be very brief. 8.68e+08. What is the difference between the Taxes (in constant 2015 US$) in Kazakhstan in 1996 and the Taxes (in constant 2015 US$) in Slovak Republic in 2000?
Give a very brief answer. -2.06e+09. What is the difference between the Taxes (in constant 2015 US$) of Papua New Guinea in 1996 and the Taxes (in constant 2015 US$) of Slovak Republic in 2000?
Your answer should be very brief. -2.85e+09. What is the difference between the Taxes (in constant 2015 US$) in Azerbaijan in 1997 and the Taxes (in constant 2015 US$) in Kazakhstan in 1998?
Provide a short and direct response. -1.03e+09. What is the difference between the Taxes (in constant 2015 US$) in Azerbaijan in 1997 and the Taxes (in constant 2015 US$) in Papua New Guinea in 1998?
Offer a terse response. 1.03e+08. What is the difference between the Taxes (in constant 2015 US$) of Azerbaijan in 1997 and the Taxes (in constant 2015 US$) of Slovak Republic in 1998?
Your response must be concise. -2.75e+09. What is the difference between the Taxes (in constant 2015 US$) in Kazakhstan in 1997 and the Taxes (in constant 2015 US$) in Papua New Guinea in 1998?
Your answer should be very brief. 8.29e+08. What is the difference between the Taxes (in constant 2015 US$) in Kazakhstan in 1997 and the Taxes (in constant 2015 US$) in Slovak Republic in 1998?
Ensure brevity in your answer.  -2.03e+09. What is the difference between the Taxes (in constant 2015 US$) in Papua New Guinea in 1997 and the Taxes (in constant 2015 US$) in Slovak Republic in 1998?
Provide a succinct answer. -2.79e+09. What is the difference between the Taxes (in constant 2015 US$) in Azerbaijan in 1997 and the Taxes (in constant 2015 US$) in Kazakhstan in 1999?
Provide a short and direct response. -6.57e+08. What is the difference between the Taxes (in constant 2015 US$) in Azerbaijan in 1997 and the Taxes (in constant 2015 US$) in Papua New Guinea in 1999?
Ensure brevity in your answer.  1.11e+08. What is the difference between the Taxes (in constant 2015 US$) in Azerbaijan in 1997 and the Taxes (in constant 2015 US$) in Slovak Republic in 1999?
Provide a succinct answer. -2.73e+09. What is the difference between the Taxes (in constant 2015 US$) in Kazakhstan in 1997 and the Taxes (in constant 2015 US$) in Papua New Guinea in 1999?
Your response must be concise. 8.37e+08. What is the difference between the Taxes (in constant 2015 US$) in Kazakhstan in 1997 and the Taxes (in constant 2015 US$) in Slovak Republic in 1999?
Offer a terse response. -2.00e+09. What is the difference between the Taxes (in constant 2015 US$) of Papua New Guinea in 1997 and the Taxes (in constant 2015 US$) of Slovak Republic in 1999?
Keep it short and to the point. -2.76e+09. What is the difference between the Taxes (in constant 2015 US$) in Azerbaijan in 1997 and the Taxes (in constant 2015 US$) in Kazakhstan in 2000?
Provide a succinct answer. -9.22e+08. What is the difference between the Taxes (in constant 2015 US$) of Azerbaijan in 1997 and the Taxes (in constant 2015 US$) of Papua New Guinea in 2000?
Ensure brevity in your answer.  1.15e+08. What is the difference between the Taxes (in constant 2015 US$) of Azerbaijan in 1997 and the Taxes (in constant 2015 US$) of Slovak Republic in 2000?
Ensure brevity in your answer.  -2.82e+09. What is the difference between the Taxes (in constant 2015 US$) in Kazakhstan in 1997 and the Taxes (in constant 2015 US$) in Papua New Guinea in 2000?
Provide a short and direct response. 8.41e+08. What is the difference between the Taxes (in constant 2015 US$) in Kazakhstan in 1997 and the Taxes (in constant 2015 US$) in Slovak Republic in 2000?
Your response must be concise. -2.09e+09. What is the difference between the Taxes (in constant 2015 US$) in Papua New Guinea in 1997 and the Taxes (in constant 2015 US$) in Slovak Republic in 2000?
Your response must be concise. -2.85e+09. What is the difference between the Taxes (in constant 2015 US$) in Azerbaijan in 1998 and the Taxes (in constant 2015 US$) in Kazakhstan in 1999?
Offer a terse response. -7.67e+08. What is the difference between the Taxes (in constant 2015 US$) of Azerbaijan in 1998 and the Taxes (in constant 2015 US$) of Papua New Guinea in 1999?
Your response must be concise. 1.32e+06. What is the difference between the Taxes (in constant 2015 US$) of Azerbaijan in 1998 and the Taxes (in constant 2015 US$) of Slovak Republic in 1999?
Your answer should be compact. -2.84e+09. What is the difference between the Taxes (in constant 2015 US$) of Kazakhstan in 1998 and the Taxes (in constant 2015 US$) of Papua New Guinea in 1999?
Your response must be concise. 1.14e+09. What is the difference between the Taxes (in constant 2015 US$) of Kazakhstan in 1998 and the Taxes (in constant 2015 US$) of Slovak Republic in 1999?
Your answer should be very brief. -1.70e+09. What is the difference between the Taxes (in constant 2015 US$) of Papua New Guinea in 1998 and the Taxes (in constant 2015 US$) of Slovak Republic in 1999?
Keep it short and to the point. -2.83e+09. What is the difference between the Taxes (in constant 2015 US$) in Azerbaijan in 1998 and the Taxes (in constant 2015 US$) in Kazakhstan in 2000?
Offer a very short reply. -1.03e+09. What is the difference between the Taxes (in constant 2015 US$) of Azerbaijan in 1998 and the Taxes (in constant 2015 US$) of Papua New Guinea in 2000?
Ensure brevity in your answer.  5.47e+06. What is the difference between the Taxes (in constant 2015 US$) of Azerbaijan in 1998 and the Taxes (in constant 2015 US$) of Slovak Republic in 2000?
Ensure brevity in your answer.  -2.93e+09. What is the difference between the Taxes (in constant 2015 US$) in Kazakhstan in 1998 and the Taxes (in constant 2015 US$) in Papua New Guinea in 2000?
Ensure brevity in your answer.  1.15e+09. What is the difference between the Taxes (in constant 2015 US$) of Kazakhstan in 1998 and the Taxes (in constant 2015 US$) of Slovak Republic in 2000?
Make the answer very short. -1.79e+09. What is the difference between the Taxes (in constant 2015 US$) in Papua New Guinea in 1998 and the Taxes (in constant 2015 US$) in Slovak Republic in 2000?
Provide a succinct answer. -2.92e+09. What is the difference between the Taxes (in constant 2015 US$) in Azerbaijan in 1999 and the Taxes (in constant 2015 US$) in Kazakhstan in 2000?
Provide a succinct answer. -1.03e+09. What is the difference between the Taxes (in constant 2015 US$) in Azerbaijan in 1999 and the Taxes (in constant 2015 US$) in Papua New Guinea in 2000?
Keep it short and to the point. 3.30e+06. What is the difference between the Taxes (in constant 2015 US$) of Azerbaijan in 1999 and the Taxes (in constant 2015 US$) of Slovak Republic in 2000?
Offer a terse response. -2.93e+09. What is the difference between the Taxes (in constant 2015 US$) of Kazakhstan in 1999 and the Taxes (in constant 2015 US$) of Papua New Guinea in 2000?
Offer a very short reply. 7.72e+08. What is the difference between the Taxes (in constant 2015 US$) of Kazakhstan in 1999 and the Taxes (in constant 2015 US$) of Slovak Republic in 2000?
Provide a short and direct response. -2.16e+09. What is the difference between the Taxes (in constant 2015 US$) in Papua New Guinea in 1999 and the Taxes (in constant 2015 US$) in Slovak Republic in 2000?
Your answer should be very brief. -2.93e+09. What is the average Taxes (in constant 2015 US$) in Azerbaijan per year?
Keep it short and to the point. 2.25e+08. What is the average Taxes (in constant 2015 US$) of Kazakhstan per year?
Offer a very short reply. 1.07e+09. What is the average Taxes (in constant 2015 US$) in Papua New Guinea per year?
Make the answer very short. 2.16e+08. What is the average Taxes (in constant 2015 US$) of Slovak Republic per year?
Your answer should be compact. 2.58e+09. In the year 1993, what is the difference between the Taxes (in constant 2015 US$) of Azerbaijan and Taxes (in constant 2015 US$) of Kazakhstan?
Keep it short and to the point. -1.24e+09. In the year 1993, what is the difference between the Taxes (in constant 2015 US$) of Azerbaijan and Taxes (in constant 2015 US$) of Papua New Guinea?
Your answer should be very brief. -5.52e+06. In the year 1993, what is the difference between the Taxes (in constant 2015 US$) in Azerbaijan and Taxes (in constant 2015 US$) in Slovak Republic?
Offer a very short reply. -1.13e+09. In the year 1993, what is the difference between the Taxes (in constant 2015 US$) of Kazakhstan and Taxes (in constant 2015 US$) of Papua New Guinea?
Your response must be concise. 1.23e+09. In the year 1993, what is the difference between the Taxes (in constant 2015 US$) in Kazakhstan and Taxes (in constant 2015 US$) in Slovak Republic?
Your response must be concise. 1.10e+08. In the year 1993, what is the difference between the Taxes (in constant 2015 US$) in Papua New Guinea and Taxes (in constant 2015 US$) in Slovak Republic?
Provide a short and direct response. -1.12e+09. In the year 1994, what is the difference between the Taxes (in constant 2015 US$) of Azerbaijan and Taxes (in constant 2015 US$) of Kazakhstan?
Offer a very short reply. -6.30e+08. In the year 1994, what is the difference between the Taxes (in constant 2015 US$) in Azerbaijan and Taxes (in constant 2015 US$) in Papua New Guinea?
Provide a succinct answer. -1.79e+08. In the year 1994, what is the difference between the Taxes (in constant 2015 US$) in Azerbaijan and Taxes (in constant 2015 US$) in Slovak Republic?
Your answer should be very brief. -2.09e+09. In the year 1994, what is the difference between the Taxes (in constant 2015 US$) of Kazakhstan and Taxes (in constant 2015 US$) of Papua New Guinea?
Provide a succinct answer. 4.50e+08. In the year 1994, what is the difference between the Taxes (in constant 2015 US$) in Kazakhstan and Taxes (in constant 2015 US$) in Slovak Republic?
Provide a short and direct response. -1.46e+09. In the year 1994, what is the difference between the Taxes (in constant 2015 US$) in Papua New Guinea and Taxes (in constant 2015 US$) in Slovak Republic?
Give a very brief answer. -1.91e+09. In the year 1995, what is the difference between the Taxes (in constant 2015 US$) of Azerbaijan and Taxes (in constant 2015 US$) of Kazakhstan?
Ensure brevity in your answer.  -6.54e+08. In the year 1995, what is the difference between the Taxes (in constant 2015 US$) in Azerbaijan and Taxes (in constant 2015 US$) in Papua New Guinea?
Give a very brief answer. 1.74e+07. In the year 1995, what is the difference between the Taxes (in constant 2015 US$) in Azerbaijan and Taxes (in constant 2015 US$) in Slovak Republic?
Your answer should be very brief. -2.38e+09. In the year 1995, what is the difference between the Taxes (in constant 2015 US$) in Kazakhstan and Taxes (in constant 2015 US$) in Papua New Guinea?
Ensure brevity in your answer.  6.72e+08. In the year 1995, what is the difference between the Taxes (in constant 2015 US$) in Kazakhstan and Taxes (in constant 2015 US$) in Slovak Republic?
Offer a very short reply. -1.72e+09. In the year 1995, what is the difference between the Taxes (in constant 2015 US$) in Papua New Guinea and Taxes (in constant 2015 US$) in Slovak Republic?
Offer a very short reply. -2.39e+09. In the year 1996, what is the difference between the Taxes (in constant 2015 US$) in Azerbaijan and Taxes (in constant 2015 US$) in Kazakhstan?
Your response must be concise. -7.26e+08. In the year 1996, what is the difference between the Taxes (in constant 2015 US$) of Azerbaijan and Taxes (in constant 2015 US$) of Papua New Guinea?
Your answer should be very brief. 6.23e+07. In the year 1996, what is the difference between the Taxes (in constant 2015 US$) of Azerbaijan and Taxes (in constant 2015 US$) of Slovak Republic?
Provide a short and direct response. -2.41e+09. In the year 1996, what is the difference between the Taxes (in constant 2015 US$) of Kazakhstan and Taxes (in constant 2015 US$) of Papua New Guinea?
Provide a succinct answer. 7.89e+08. In the year 1996, what is the difference between the Taxes (in constant 2015 US$) in Kazakhstan and Taxes (in constant 2015 US$) in Slovak Republic?
Offer a very short reply. -1.68e+09. In the year 1996, what is the difference between the Taxes (in constant 2015 US$) in Papua New Guinea and Taxes (in constant 2015 US$) in Slovak Republic?
Your response must be concise. -2.47e+09. In the year 1997, what is the difference between the Taxes (in constant 2015 US$) of Azerbaijan and Taxes (in constant 2015 US$) of Kazakhstan?
Your answer should be compact. -7.26e+08. In the year 1997, what is the difference between the Taxes (in constant 2015 US$) of Azerbaijan and Taxes (in constant 2015 US$) of Papua New Guinea?
Keep it short and to the point. 3.49e+07. In the year 1997, what is the difference between the Taxes (in constant 2015 US$) of Azerbaijan and Taxes (in constant 2015 US$) of Slovak Republic?
Provide a succinct answer. -2.33e+09. In the year 1997, what is the difference between the Taxes (in constant 2015 US$) in Kazakhstan and Taxes (in constant 2015 US$) in Papua New Guinea?
Offer a terse response. 7.61e+08. In the year 1997, what is the difference between the Taxes (in constant 2015 US$) in Kazakhstan and Taxes (in constant 2015 US$) in Slovak Republic?
Give a very brief answer. -1.60e+09. In the year 1997, what is the difference between the Taxes (in constant 2015 US$) in Papua New Guinea and Taxes (in constant 2015 US$) in Slovak Republic?
Give a very brief answer. -2.36e+09. In the year 1998, what is the difference between the Taxes (in constant 2015 US$) of Azerbaijan and Taxes (in constant 2015 US$) of Kazakhstan?
Your answer should be compact. -1.14e+09. In the year 1998, what is the difference between the Taxes (in constant 2015 US$) in Azerbaijan and Taxes (in constant 2015 US$) in Papua New Guinea?
Your answer should be compact. -7.25e+06. In the year 1998, what is the difference between the Taxes (in constant 2015 US$) in Azerbaijan and Taxes (in constant 2015 US$) in Slovak Republic?
Provide a succinct answer. -2.86e+09. In the year 1998, what is the difference between the Taxes (in constant 2015 US$) of Kazakhstan and Taxes (in constant 2015 US$) of Papua New Guinea?
Offer a terse response. 1.13e+09. In the year 1998, what is the difference between the Taxes (in constant 2015 US$) in Kazakhstan and Taxes (in constant 2015 US$) in Slovak Republic?
Make the answer very short. -1.72e+09. In the year 1998, what is the difference between the Taxes (in constant 2015 US$) of Papua New Guinea and Taxes (in constant 2015 US$) of Slovak Republic?
Your answer should be very brief. -2.86e+09. In the year 1999, what is the difference between the Taxes (in constant 2015 US$) of Azerbaijan and Taxes (in constant 2015 US$) of Kazakhstan?
Your answer should be very brief. -7.69e+08. In the year 1999, what is the difference between the Taxes (in constant 2015 US$) of Azerbaijan and Taxes (in constant 2015 US$) of Papua New Guinea?
Your response must be concise. -8.47e+05. In the year 1999, what is the difference between the Taxes (in constant 2015 US$) of Azerbaijan and Taxes (in constant 2015 US$) of Slovak Republic?
Offer a terse response. -2.84e+09. In the year 1999, what is the difference between the Taxes (in constant 2015 US$) in Kazakhstan and Taxes (in constant 2015 US$) in Papua New Guinea?
Your answer should be very brief. 7.68e+08. In the year 1999, what is the difference between the Taxes (in constant 2015 US$) of Kazakhstan and Taxes (in constant 2015 US$) of Slovak Republic?
Your answer should be very brief. -2.07e+09. In the year 1999, what is the difference between the Taxes (in constant 2015 US$) in Papua New Guinea and Taxes (in constant 2015 US$) in Slovak Republic?
Offer a very short reply. -2.84e+09. In the year 2000, what is the difference between the Taxes (in constant 2015 US$) in Azerbaijan and Taxes (in constant 2015 US$) in Kazakhstan?
Offer a terse response. -8.90e+08. In the year 2000, what is the difference between the Taxes (in constant 2015 US$) in Azerbaijan and Taxes (in constant 2015 US$) in Papua New Guinea?
Provide a short and direct response. 1.48e+08. In the year 2000, what is the difference between the Taxes (in constant 2015 US$) in Azerbaijan and Taxes (in constant 2015 US$) in Slovak Republic?
Provide a short and direct response. -2.79e+09. In the year 2000, what is the difference between the Taxes (in constant 2015 US$) in Kazakhstan and Taxes (in constant 2015 US$) in Papua New Guinea?
Give a very brief answer. 1.04e+09. In the year 2000, what is the difference between the Taxes (in constant 2015 US$) in Kazakhstan and Taxes (in constant 2015 US$) in Slovak Republic?
Ensure brevity in your answer.  -1.90e+09. In the year 2000, what is the difference between the Taxes (in constant 2015 US$) of Papua New Guinea and Taxes (in constant 2015 US$) of Slovak Republic?
Provide a succinct answer. -2.93e+09. What is the ratio of the Taxes (in constant 2015 US$) of Azerbaijan in 1993 to that in 1994?
Provide a short and direct response. 3. What is the ratio of the Taxes (in constant 2015 US$) of Kazakhstan in 1993 to that in 1994?
Make the answer very short. 2.06. What is the ratio of the Taxes (in constant 2015 US$) of Papua New Guinea in 1993 to that in 1994?
Your answer should be very brief. 0.82. What is the ratio of the Taxes (in constant 2015 US$) of Slovak Republic in 1993 to that in 1994?
Your answer should be compact. 0.61. What is the ratio of the Taxes (in constant 2015 US$) of Azerbaijan in 1993 to that in 1995?
Keep it short and to the point. 0.82. What is the ratio of the Taxes (in constant 2015 US$) of Kazakhstan in 1993 to that in 1995?
Keep it short and to the point. 1.61. What is the ratio of the Taxes (in constant 2015 US$) of Papua New Guinea in 1993 to that in 1995?
Provide a short and direct response. 0.91. What is the ratio of the Taxes (in constant 2015 US$) of Slovak Republic in 1993 to that in 1995?
Ensure brevity in your answer.  0.51. What is the ratio of the Taxes (in constant 2015 US$) in Azerbaijan in 1993 to that in 1996?
Provide a succinct answer. 0.61. What is the ratio of the Taxes (in constant 2015 US$) of Kazakhstan in 1993 to that in 1996?
Offer a very short reply. 1.37. What is the ratio of the Taxes (in constant 2015 US$) of Papua New Guinea in 1993 to that in 1996?
Your response must be concise. 0.78. What is the ratio of the Taxes (in constant 2015 US$) of Slovak Republic in 1993 to that in 1996?
Your response must be concise. 0.48. What is the ratio of the Taxes (in constant 2015 US$) of Azerbaijan in 1993 to that in 1997?
Offer a terse response. 0.66. What is the ratio of the Taxes (in constant 2015 US$) in Kazakhstan in 1993 to that in 1997?
Your answer should be very brief. 1.4. What is the ratio of the Taxes (in constant 2015 US$) of Papua New Guinea in 1993 to that in 1997?
Keep it short and to the point. 0.77. What is the ratio of the Taxes (in constant 2015 US$) in Slovak Republic in 1993 to that in 1997?
Give a very brief answer. 0.5. What is the ratio of the Taxes (in constant 2015 US$) in Azerbaijan in 1993 to that in 1998?
Provide a succinct answer. 1.06. What is the ratio of the Taxes (in constant 2015 US$) in Kazakhstan in 1993 to that in 1998?
Your answer should be very brief. 1.08. What is the ratio of the Taxes (in constant 2015 US$) of Papua New Guinea in 1993 to that in 1998?
Offer a very short reply. 1.05. What is the ratio of the Taxes (in constant 2015 US$) in Slovak Republic in 1993 to that in 1998?
Keep it short and to the point. 0.43. What is the ratio of the Taxes (in constant 2015 US$) of Azerbaijan in 1993 to that in 1999?
Your answer should be very brief. 1.07. What is the ratio of the Taxes (in constant 2015 US$) of Kazakhstan in 1993 to that in 1999?
Make the answer very short. 1.51. What is the ratio of the Taxes (in constant 2015 US$) of Papua New Guinea in 1993 to that in 1999?
Ensure brevity in your answer.  1.1. What is the ratio of the Taxes (in constant 2015 US$) in Slovak Republic in 1993 to that in 1999?
Offer a terse response. 0.44. What is the ratio of the Taxes (in constant 2015 US$) in Azerbaijan in 1993 to that in 2000?
Keep it short and to the point. 0.6. What is the ratio of the Taxes (in constant 2015 US$) in Kazakhstan in 1993 to that in 2000?
Provide a short and direct response. 1.18. What is the ratio of the Taxes (in constant 2015 US$) of Papua New Guinea in 1993 to that in 2000?
Your answer should be compact. 1.12. What is the ratio of the Taxes (in constant 2015 US$) in Slovak Republic in 1993 to that in 2000?
Provide a succinct answer. 0.42. What is the ratio of the Taxes (in constant 2015 US$) of Azerbaijan in 1994 to that in 1995?
Offer a terse response. 0.27. What is the ratio of the Taxes (in constant 2015 US$) of Kazakhstan in 1994 to that in 1995?
Provide a succinct answer. 0.78. What is the ratio of the Taxes (in constant 2015 US$) of Papua New Guinea in 1994 to that in 1995?
Your answer should be very brief. 1.11. What is the ratio of the Taxes (in constant 2015 US$) in Slovak Republic in 1994 to that in 1995?
Provide a short and direct response. 0.83. What is the ratio of the Taxes (in constant 2015 US$) in Azerbaijan in 1994 to that in 1996?
Your answer should be very brief. 0.2. What is the ratio of the Taxes (in constant 2015 US$) in Kazakhstan in 1994 to that in 1996?
Your answer should be compact. 0.66. What is the ratio of the Taxes (in constant 2015 US$) of Papua New Guinea in 1994 to that in 1996?
Provide a short and direct response. 0.95. What is the ratio of the Taxes (in constant 2015 US$) of Slovak Republic in 1994 to that in 1996?
Provide a short and direct response. 0.79. What is the ratio of the Taxes (in constant 2015 US$) in Azerbaijan in 1994 to that in 1997?
Your answer should be compact. 0.22. What is the ratio of the Taxes (in constant 2015 US$) in Kazakhstan in 1994 to that in 1997?
Provide a succinct answer. 0.68. What is the ratio of the Taxes (in constant 2015 US$) in Papua New Guinea in 1994 to that in 1997?
Keep it short and to the point. 0.95. What is the ratio of the Taxes (in constant 2015 US$) in Slovak Republic in 1994 to that in 1997?
Provide a short and direct response. 0.82. What is the ratio of the Taxes (in constant 2015 US$) of Azerbaijan in 1994 to that in 1998?
Give a very brief answer. 0.35. What is the ratio of the Taxes (in constant 2015 US$) in Kazakhstan in 1994 to that in 1998?
Offer a terse response. 0.52. What is the ratio of the Taxes (in constant 2015 US$) in Papua New Guinea in 1994 to that in 1998?
Ensure brevity in your answer.  1.28. What is the ratio of the Taxes (in constant 2015 US$) of Slovak Republic in 1994 to that in 1998?
Provide a short and direct response. 0.71. What is the ratio of the Taxes (in constant 2015 US$) of Azerbaijan in 1994 to that in 1999?
Provide a succinct answer. 0.36. What is the ratio of the Taxes (in constant 2015 US$) in Kazakhstan in 1994 to that in 1999?
Offer a terse response. 0.73. What is the ratio of the Taxes (in constant 2015 US$) of Papua New Guinea in 1994 to that in 1999?
Give a very brief answer. 1.34. What is the ratio of the Taxes (in constant 2015 US$) of Slovak Republic in 1994 to that in 1999?
Provide a short and direct response. 0.71. What is the ratio of the Taxes (in constant 2015 US$) in Azerbaijan in 1994 to that in 2000?
Ensure brevity in your answer.  0.2. What is the ratio of the Taxes (in constant 2015 US$) of Kazakhstan in 1994 to that in 2000?
Give a very brief answer. 0.57. What is the ratio of the Taxes (in constant 2015 US$) of Papua New Guinea in 1994 to that in 2000?
Offer a terse response. 1.37. What is the ratio of the Taxes (in constant 2015 US$) in Slovak Republic in 1994 to that in 2000?
Your answer should be compact. 0.69. What is the ratio of the Taxes (in constant 2015 US$) of Azerbaijan in 1995 to that in 1996?
Your answer should be very brief. 0.74. What is the ratio of the Taxes (in constant 2015 US$) of Kazakhstan in 1995 to that in 1996?
Provide a succinct answer. 0.85. What is the ratio of the Taxes (in constant 2015 US$) in Papua New Guinea in 1995 to that in 1996?
Give a very brief answer. 0.85. What is the ratio of the Taxes (in constant 2015 US$) of Slovak Republic in 1995 to that in 1996?
Your answer should be very brief. 0.96. What is the ratio of the Taxes (in constant 2015 US$) in Azerbaijan in 1995 to that in 1997?
Make the answer very short. 0.81. What is the ratio of the Taxes (in constant 2015 US$) in Kazakhstan in 1995 to that in 1997?
Provide a succinct answer. 0.87. What is the ratio of the Taxes (in constant 2015 US$) in Papua New Guinea in 1995 to that in 1997?
Keep it short and to the point. 0.85. What is the ratio of the Taxes (in constant 2015 US$) in Slovak Republic in 1995 to that in 1997?
Your answer should be compact. 1. What is the ratio of the Taxes (in constant 2015 US$) of Azerbaijan in 1995 to that in 1998?
Your response must be concise. 1.29. What is the ratio of the Taxes (in constant 2015 US$) in Kazakhstan in 1995 to that in 1998?
Offer a terse response. 0.67. What is the ratio of the Taxes (in constant 2015 US$) of Papua New Guinea in 1995 to that in 1998?
Make the answer very short. 1.15. What is the ratio of the Taxes (in constant 2015 US$) in Slovak Republic in 1995 to that in 1998?
Provide a succinct answer. 0.86. What is the ratio of the Taxes (in constant 2015 US$) of Azerbaijan in 1995 to that in 1999?
Offer a terse response. 1.31. What is the ratio of the Taxes (in constant 2015 US$) of Kazakhstan in 1995 to that in 1999?
Offer a very short reply. 0.94. What is the ratio of the Taxes (in constant 2015 US$) in Papua New Guinea in 1995 to that in 1999?
Your answer should be very brief. 1.2. What is the ratio of the Taxes (in constant 2015 US$) of Slovak Republic in 1995 to that in 1999?
Your answer should be very brief. 0.87. What is the ratio of the Taxes (in constant 2015 US$) in Azerbaijan in 1995 to that in 2000?
Make the answer very short. 0.73. What is the ratio of the Taxes (in constant 2015 US$) in Kazakhstan in 1995 to that in 2000?
Give a very brief answer. 0.73. What is the ratio of the Taxes (in constant 2015 US$) in Papua New Guinea in 1995 to that in 2000?
Offer a very short reply. 1.23. What is the ratio of the Taxes (in constant 2015 US$) of Slovak Republic in 1995 to that in 2000?
Offer a very short reply. 0.84. What is the ratio of the Taxes (in constant 2015 US$) in Azerbaijan in 1996 to that in 1997?
Provide a short and direct response. 1.09. What is the ratio of the Taxes (in constant 2015 US$) in Kazakhstan in 1996 to that in 1997?
Make the answer very short. 1.03. What is the ratio of the Taxes (in constant 2015 US$) of Papua New Guinea in 1996 to that in 1997?
Give a very brief answer. 1. What is the ratio of the Taxes (in constant 2015 US$) in Slovak Republic in 1996 to that in 1997?
Provide a short and direct response. 1.04. What is the ratio of the Taxes (in constant 2015 US$) of Azerbaijan in 1996 to that in 1998?
Provide a short and direct response. 1.75. What is the ratio of the Taxes (in constant 2015 US$) of Kazakhstan in 1996 to that in 1998?
Offer a very short reply. 0.79. What is the ratio of the Taxes (in constant 2015 US$) in Papua New Guinea in 1996 to that in 1998?
Your answer should be compact. 1.35. What is the ratio of the Taxes (in constant 2015 US$) in Slovak Republic in 1996 to that in 1998?
Ensure brevity in your answer.  0.9. What is the ratio of the Taxes (in constant 2015 US$) in Azerbaijan in 1996 to that in 1999?
Make the answer very short. 1.77. What is the ratio of the Taxes (in constant 2015 US$) of Kazakhstan in 1996 to that in 1999?
Keep it short and to the point. 1.1. What is the ratio of the Taxes (in constant 2015 US$) in Papua New Guinea in 1996 to that in 1999?
Give a very brief answer. 1.42. What is the ratio of the Taxes (in constant 2015 US$) in Slovak Republic in 1996 to that in 1999?
Your answer should be very brief. 0.9. What is the ratio of the Taxes (in constant 2015 US$) in Azerbaijan in 1996 to that in 2000?
Ensure brevity in your answer.  0.98. What is the ratio of the Taxes (in constant 2015 US$) of Kazakhstan in 1996 to that in 2000?
Your response must be concise. 0.86. What is the ratio of the Taxes (in constant 2015 US$) in Papua New Guinea in 1996 to that in 2000?
Offer a terse response. 1.45. What is the ratio of the Taxes (in constant 2015 US$) of Slovak Republic in 1996 to that in 2000?
Provide a succinct answer. 0.88. What is the ratio of the Taxes (in constant 2015 US$) in Azerbaijan in 1997 to that in 1998?
Offer a terse response. 1.6. What is the ratio of the Taxes (in constant 2015 US$) of Kazakhstan in 1997 to that in 1998?
Your response must be concise. 0.77. What is the ratio of the Taxes (in constant 2015 US$) of Papua New Guinea in 1997 to that in 1998?
Make the answer very short. 1.36. What is the ratio of the Taxes (in constant 2015 US$) in Slovak Republic in 1997 to that in 1998?
Your answer should be very brief. 0.86. What is the ratio of the Taxes (in constant 2015 US$) of Azerbaijan in 1997 to that in 1999?
Make the answer very short. 1.62. What is the ratio of the Taxes (in constant 2015 US$) of Kazakhstan in 1997 to that in 1999?
Ensure brevity in your answer.  1.07. What is the ratio of the Taxes (in constant 2015 US$) of Papua New Guinea in 1997 to that in 1999?
Provide a succinct answer. 1.42. What is the ratio of the Taxes (in constant 2015 US$) of Slovak Republic in 1997 to that in 1999?
Offer a very short reply. 0.87. What is the ratio of the Taxes (in constant 2015 US$) of Azerbaijan in 1997 to that in 2000?
Provide a short and direct response. 0.9. What is the ratio of the Taxes (in constant 2015 US$) of Kazakhstan in 1997 to that in 2000?
Provide a short and direct response. 0.84. What is the ratio of the Taxes (in constant 2015 US$) of Papua New Guinea in 1997 to that in 2000?
Keep it short and to the point. 1.45. What is the ratio of the Taxes (in constant 2015 US$) in Slovak Republic in 1997 to that in 2000?
Offer a terse response. 0.84. What is the ratio of the Taxes (in constant 2015 US$) of Kazakhstan in 1998 to that in 1999?
Provide a short and direct response. 1.39. What is the ratio of the Taxes (in constant 2015 US$) of Papua New Guinea in 1998 to that in 1999?
Make the answer very short. 1.05. What is the ratio of the Taxes (in constant 2015 US$) of Slovak Republic in 1998 to that in 1999?
Offer a very short reply. 1.01. What is the ratio of the Taxes (in constant 2015 US$) in Azerbaijan in 1998 to that in 2000?
Provide a short and direct response. 0.56. What is the ratio of the Taxes (in constant 2015 US$) in Kazakhstan in 1998 to that in 2000?
Offer a terse response. 1.09. What is the ratio of the Taxes (in constant 2015 US$) of Papua New Guinea in 1998 to that in 2000?
Ensure brevity in your answer.  1.07. What is the ratio of the Taxes (in constant 2015 US$) of Slovak Republic in 1998 to that in 2000?
Make the answer very short. 0.98. What is the ratio of the Taxes (in constant 2015 US$) of Azerbaijan in 1999 to that in 2000?
Offer a very short reply. 0.56. What is the ratio of the Taxes (in constant 2015 US$) in Kazakhstan in 1999 to that in 2000?
Your answer should be compact. 0.78. What is the ratio of the Taxes (in constant 2015 US$) of Papua New Guinea in 1999 to that in 2000?
Provide a succinct answer. 1.02. What is the ratio of the Taxes (in constant 2015 US$) of Slovak Republic in 1999 to that in 2000?
Your response must be concise. 0.97. What is the difference between the highest and the second highest Taxes (in constant 2015 US$) in Azerbaijan?
Ensure brevity in your answer.  5.73e+06. What is the difference between the highest and the second highest Taxes (in constant 2015 US$) in Kazakhstan?
Provide a short and direct response. 1.06e+08. What is the difference between the highest and the second highest Taxes (in constant 2015 US$) in Papua New Guinea?
Offer a terse response. 7.72e+05. What is the difference between the highest and the second highest Taxes (in constant 2015 US$) in Slovak Republic?
Ensure brevity in your answer.  6.50e+07. What is the difference between the highest and the lowest Taxes (in constant 2015 US$) in Azerbaijan?
Offer a terse response. 2.61e+08. What is the difference between the highest and the lowest Taxes (in constant 2015 US$) in Kazakhstan?
Ensure brevity in your answer.  7.35e+08. What is the difference between the highest and the lowest Taxes (in constant 2015 US$) of Papua New Guinea?
Your response must be concise. 8.04e+07. What is the difference between the highest and the lowest Taxes (in constant 2015 US$) of Slovak Republic?
Your answer should be compact. 1.79e+09. 